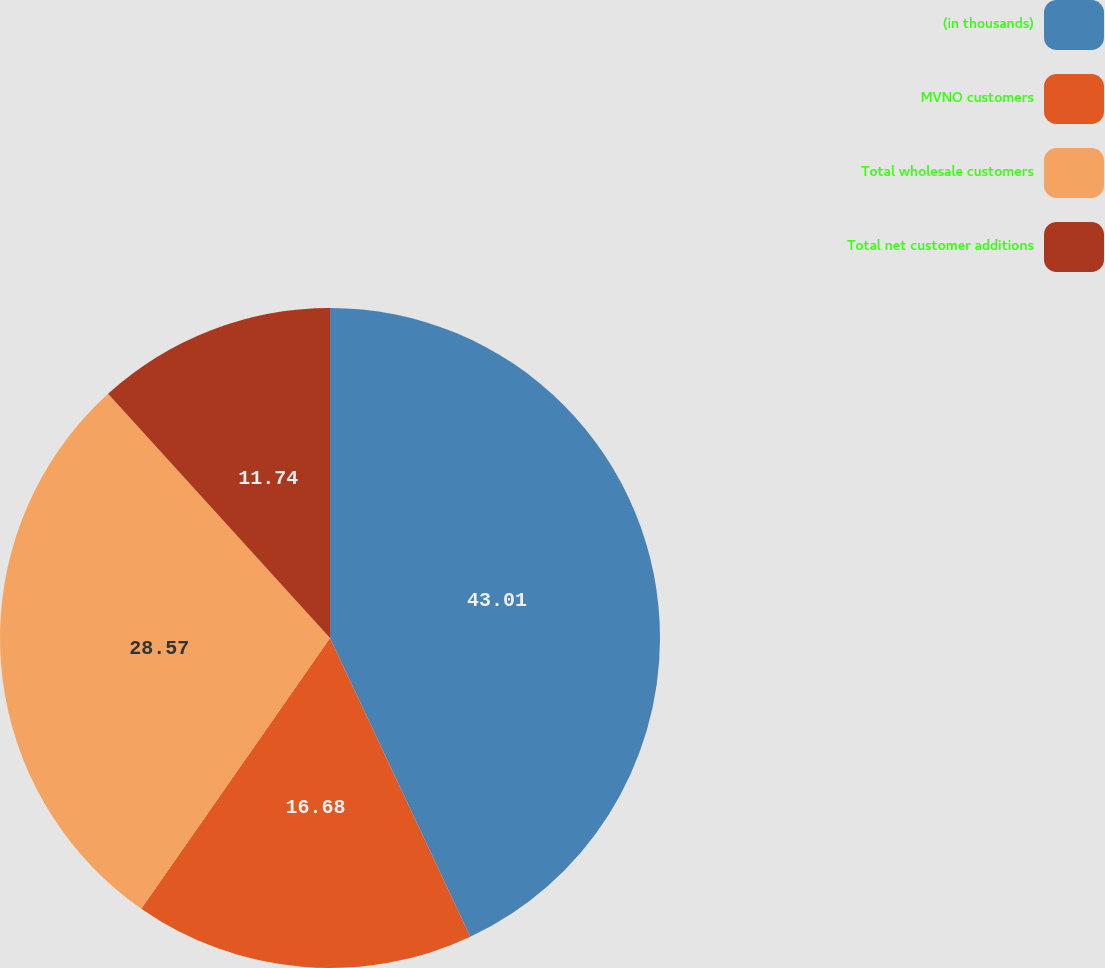<chart> <loc_0><loc_0><loc_500><loc_500><pie_chart><fcel>(in thousands)<fcel>MVNO customers<fcel>Total wholesale customers<fcel>Total net customer additions<nl><fcel>43.01%<fcel>16.68%<fcel>28.57%<fcel>11.74%<nl></chart> 